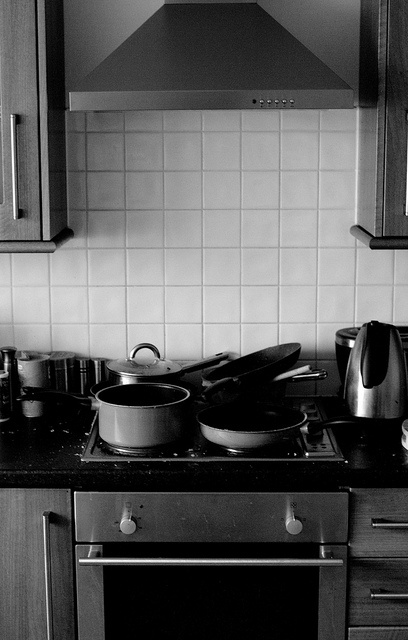Describe the objects in this image and their specific colors. I can see a oven in gray, black, darkgray, and lightgray tones in this image. 